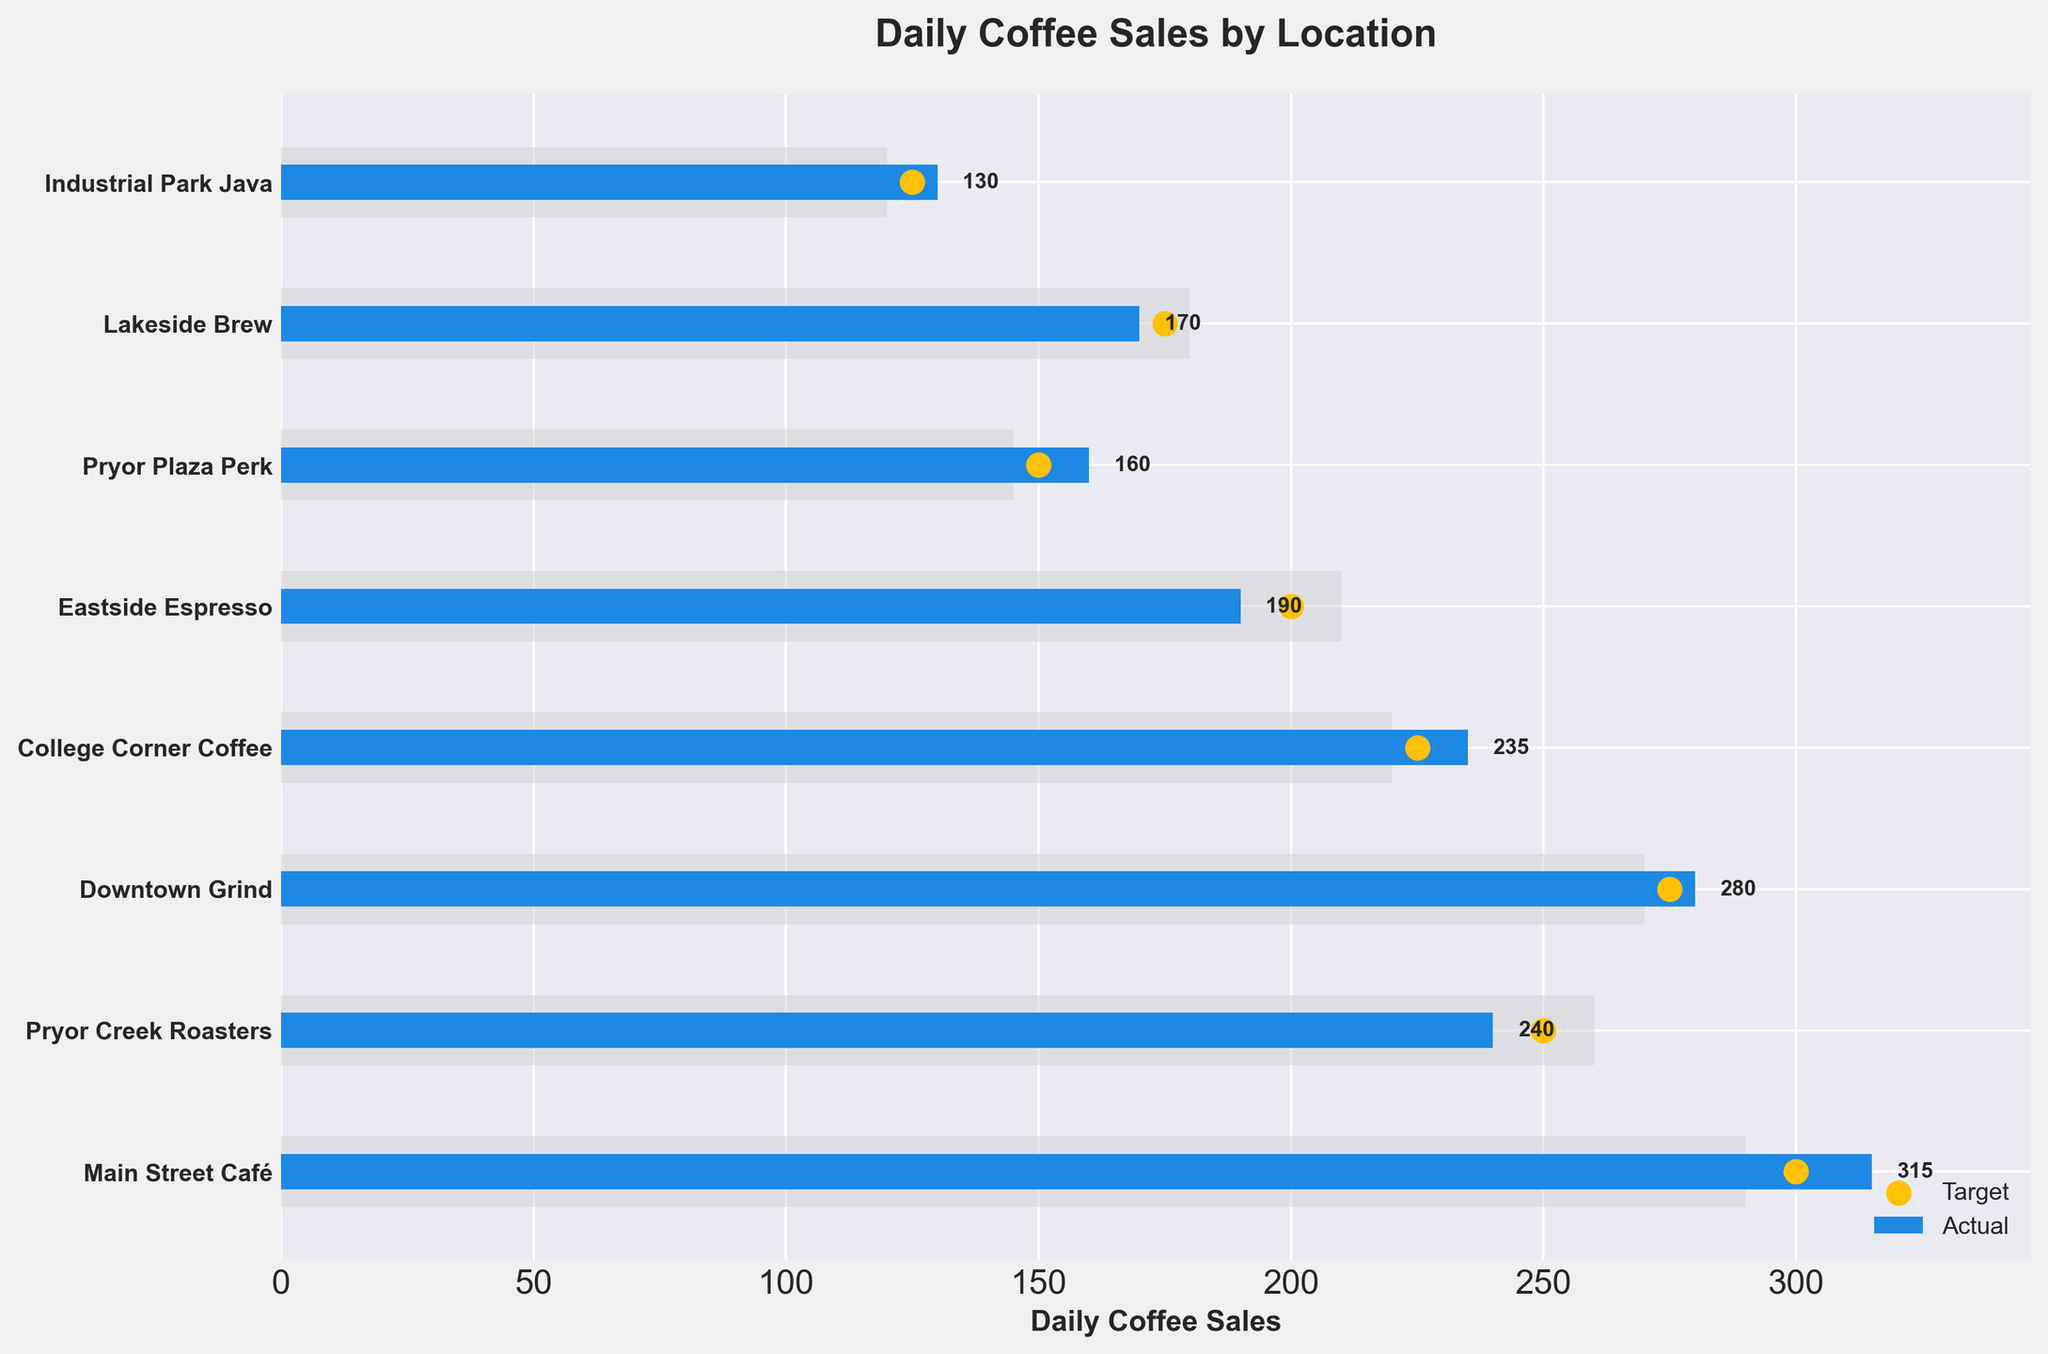What's the title of the figure? The title is usually displayed at the top of the figure. In this plot, it's prominently displayed there.
Answer: Daily Coffee Sales by Location What does the yellow color in the plot represent? The yellow color, based on the legend at the bottom right of the plot, represents the Target measure for each location.
Answer: Target Which location has the highest actual coffee sales? The locations are shown on the y-axis, and the highest actual sales can be determined by the longest blue bar. From the figure, it's Main Street Café.
Answer: Main Street Café How many locations have actual sales that exceeded their targets? Compare the blue bar (actual sales) with the yellow dot (target) for each location. Locations where the blue bar extends further right than the yellow dot have exceeded their targets. These locations are Main Street Café, Downtown Grind, College Corner Coffee, Pryor Plaza Perk, and Industrial Park Java.
Answer: 5 What's the difference between the target and actual sales for Pryor Creek Roasters? Look at the position of the yellow dot and the length of the blue bar for Pryor Creek Roasters. The target is 250, and the actual sales are 240. The difference is 250 - 240.
Answer: 10 Which location has the closest actual sales to their comparative measure? The closest actual sales to the comparative measure are where the blue bar (actual sales) and the light grey bar (comparative) are closest in length. For Pryor Creek Roasters, actual sales (240) and comparative measure (260) are very close. The difference here is 20.
Answer: Pryor Creek Roasters What is the median target sales value across all locations? To find the median target sales value, list the target values in ascending order (125, 150, 175, 200, 225, 250, 275, 300) and find the middle value(s). Since there are 8 data points, the median is the average of the 4th and 5th values: (200+225)/2.
Answer: 212.5 Which location has the largest discrepancy between actual sales and target sales? Calculate the discrepancy for each location by taking the absolute difference between actual sales and target sales. The largest difference is for Main Street Café with a discrepancy of 315 - 300.
Answer: 15 What is the average actual sales value across all locations? Add up all the actual sales values and divide by the number of locations: (315 + 240 + 280 + 235 + 190 + 160 + 170 + 130) / 8. The sum is 1720, and the average is 1720 / 8.
Answer: 215 How many locations have comparative measures higher than their actual sales? Compare the grey bar (comparative measure) with the blue bar (actual sales) for each location. If the grey bar is longer, then the comparative measure is higher. These locations are Pryor Creek Roasters, Eastside Espresso, and Lakeside Brew.
Answer: 3 